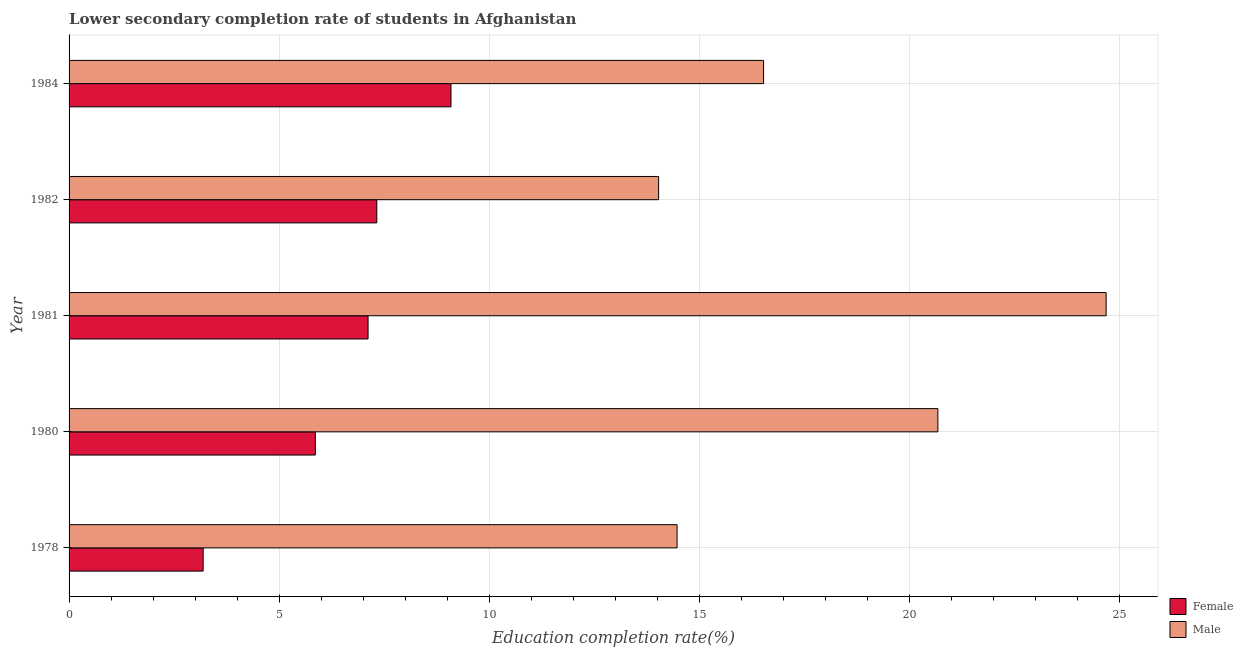How many different coloured bars are there?
Make the answer very short. 2. How many groups of bars are there?
Keep it short and to the point. 5. Are the number of bars per tick equal to the number of legend labels?
Your answer should be compact. Yes. Are the number of bars on each tick of the Y-axis equal?
Offer a very short reply. Yes. In how many cases, is the number of bars for a given year not equal to the number of legend labels?
Ensure brevity in your answer.  0. What is the education completion rate of male students in 1981?
Ensure brevity in your answer.  24.69. Across all years, what is the maximum education completion rate of male students?
Keep it short and to the point. 24.69. Across all years, what is the minimum education completion rate of male students?
Provide a succinct answer. 14.03. In which year was the education completion rate of male students maximum?
Ensure brevity in your answer.  1981. In which year was the education completion rate of female students minimum?
Provide a succinct answer. 1978. What is the total education completion rate of female students in the graph?
Provide a short and direct response. 32.59. What is the difference between the education completion rate of female students in 1982 and that in 1984?
Your response must be concise. -1.77. What is the difference between the education completion rate of female students in 1980 and the education completion rate of male students in 1984?
Provide a short and direct response. -10.67. What is the average education completion rate of female students per year?
Your answer should be very brief. 6.52. In the year 1982, what is the difference between the education completion rate of female students and education completion rate of male students?
Your response must be concise. -6.71. What is the ratio of the education completion rate of female students in 1981 to that in 1984?
Your answer should be very brief. 0.78. Is the education completion rate of male students in 1981 less than that in 1982?
Make the answer very short. No. Is the difference between the education completion rate of male students in 1978 and 1984 greater than the difference between the education completion rate of female students in 1978 and 1984?
Offer a very short reply. Yes. What is the difference between the highest and the second highest education completion rate of male students?
Make the answer very short. 4. What is the difference between the highest and the lowest education completion rate of male students?
Provide a short and direct response. 10.65. Is the sum of the education completion rate of female students in 1978 and 1980 greater than the maximum education completion rate of male students across all years?
Your answer should be compact. No. What does the 2nd bar from the top in 1984 represents?
Ensure brevity in your answer.  Female. What does the 1st bar from the bottom in 1978 represents?
Your answer should be very brief. Female. Are all the bars in the graph horizontal?
Ensure brevity in your answer.  Yes. How many years are there in the graph?
Provide a succinct answer. 5. What is the difference between two consecutive major ticks on the X-axis?
Your response must be concise. 5. Are the values on the major ticks of X-axis written in scientific E-notation?
Keep it short and to the point. No. Does the graph contain any zero values?
Your answer should be compact. No. Where does the legend appear in the graph?
Offer a terse response. Bottom right. What is the title of the graph?
Provide a succinct answer. Lower secondary completion rate of students in Afghanistan. What is the label or title of the X-axis?
Make the answer very short. Education completion rate(%). What is the Education completion rate(%) in Female in 1978?
Your answer should be compact. 3.19. What is the Education completion rate(%) in Male in 1978?
Provide a succinct answer. 14.47. What is the Education completion rate(%) of Female in 1980?
Your answer should be very brief. 5.86. What is the Education completion rate(%) in Male in 1980?
Offer a terse response. 20.68. What is the Education completion rate(%) of Female in 1981?
Give a very brief answer. 7.12. What is the Education completion rate(%) in Male in 1981?
Provide a succinct answer. 24.69. What is the Education completion rate(%) in Female in 1982?
Your response must be concise. 7.33. What is the Education completion rate(%) of Male in 1982?
Your response must be concise. 14.03. What is the Education completion rate(%) of Female in 1984?
Your answer should be compact. 9.09. What is the Education completion rate(%) of Male in 1984?
Ensure brevity in your answer.  16.53. Across all years, what is the maximum Education completion rate(%) of Female?
Keep it short and to the point. 9.09. Across all years, what is the maximum Education completion rate(%) of Male?
Make the answer very short. 24.69. Across all years, what is the minimum Education completion rate(%) of Female?
Keep it short and to the point. 3.19. Across all years, what is the minimum Education completion rate(%) in Male?
Make the answer very short. 14.03. What is the total Education completion rate(%) in Female in the graph?
Ensure brevity in your answer.  32.59. What is the total Education completion rate(%) in Male in the graph?
Offer a very short reply. 90.41. What is the difference between the Education completion rate(%) in Female in 1978 and that in 1980?
Ensure brevity in your answer.  -2.67. What is the difference between the Education completion rate(%) of Male in 1978 and that in 1980?
Offer a terse response. -6.21. What is the difference between the Education completion rate(%) in Female in 1978 and that in 1981?
Offer a very short reply. -3.93. What is the difference between the Education completion rate(%) in Male in 1978 and that in 1981?
Offer a terse response. -10.21. What is the difference between the Education completion rate(%) of Female in 1978 and that in 1982?
Your response must be concise. -4.13. What is the difference between the Education completion rate(%) in Male in 1978 and that in 1982?
Keep it short and to the point. 0.44. What is the difference between the Education completion rate(%) of Female in 1978 and that in 1984?
Offer a terse response. -5.9. What is the difference between the Education completion rate(%) in Male in 1978 and that in 1984?
Keep it short and to the point. -2.06. What is the difference between the Education completion rate(%) in Female in 1980 and that in 1981?
Offer a very short reply. -1.25. What is the difference between the Education completion rate(%) in Male in 1980 and that in 1981?
Your answer should be compact. -4.01. What is the difference between the Education completion rate(%) of Female in 1980 and that in 1982?
Your answer should be very brief. -1.46. What is the difference between the Education completion rate(%) in Male in 1980 and that in 1982?
Give a very brief answer. 6.65. What is the difference between the Education completion rate(%) in Female in 1980 and that in 1984?
Provide a succinct answer. -3.23. What is the difference between the Education completion rate(%) in Male in 1980 and that in 1984?
Provide a succinct answer. 4.15. What is the difference between the Education completion rate(%) of Female in 1981 and that in 1982?
Provide a succinct answer. -0.21. What is the difference between the Education completion rate(%) in Male in 1981 and that in 1982?
Provide a succinct answer. 10.65. What is the difference between the Education completion rate(%) in Female in 1981 and that in 1984?
Your response must be concise. -1.97. What is the difference between the Education completion rate(%) in Male in 1981 and that in 1984?
Provide a short and direct response. 8.15. What is the difference between the Education completion rate(%) of Female in 1982 and that in 1984?
Provide a succinct answer. -1.77. What is the difference between the Education completion rate(%) in Male in 1982 and that in 1984?
Give a very brief answer. -2.5. What is the difference between the Education completion rate(%) of Female in 1978 and the Education completion rate(%) of Male in 1980?
Make the answer very short. -17.49. What is the difference between the Education completion rate(%) in Female in 1978 and the Education completion rate(%) in Male in 1981?
Keep it short and to the point. -21.49. What is the difference between the Education completion rate(%) in Female in 1978 and the Education completion rate(%) in Male in 1982?
Provide a short and direct response. -10.84. What is the difference between the Education completion rate(%) in Female in 1978 and the Education completion rate(%) in Male in 1984?
Make the answer very short. -13.34. What is the difference between the Education completion rate(%) in Female in 1980 and the Education completion rate(%) in Male in 1981?
Make the answer very short. -18.82. What is the difference between the Education completion rate(%) in Female in 1980 and the Education completion rate(%) in Male in 1982?
Your answer should be compact. -8.17. What is the difference between the Education completion rate(%) in Female in 1980 and the Education completion rate(%) in Male in 1984?
Offer a very short reply. -10.67. What is the difference between the Education completion rate(%) of Female in 1981 and the Education completion rate(%) of Male in 1982?
Offer a terse response. -6.92. What is the difference between the Education completion rate(%) in Female in 1981 and the Education completion rate(%) in Male in 1984?
Ensure brevity in your answer.  -9.41. What is the difference between the Education completion rate(%) in Female in 1982 and the Education completion rate(%) in Male in 1984?
Provide a short and direct response. -9.21. What is the average Education completion rate(%) of Female per year?
Make the answer very short. 6.52. What is the average Education completion rate(%) in Male per year?
Offer a terse response. 18.08. In the year 1978, what is the difference between the Education completion rate(%) in Female and Education completion rate(%) in Male?
Your answer should be very brief. -11.28. In the year 1980, what is the difference between the Education completion rate(%) in Female and Education completion rate(%) in Male?
Give a very brief answer. -14.82. In the year 1981, what is the difference between the Education completion rate(%) in Female and Education completion rate(%) in Male?
Give a very brief answer. -17.57. In the year 1982, what is the difference between the Education completion rate(%) of Female and Education completion rate(%) of Male?
Provide a succinct answer. -6.71. In the year 1984, what is the difference between the Education completion rate(%) in Female and Education completion rate(%) in Male?
Offer a terse response. -7.44. What is the ratio of the Education completion rate(%) of Female in 1978 to that in 1980?
Give a very brief answer. 0.54. What is the ratio of the Education completion rate(%) in Male in 1978 to that in 1980?
Your answer should be very brief. 0.7. What is the ratio of the Education completion rate(%) in Female in 1978 to that in 1981?
Ensure brevity in your answer.  0.45. What is the ratio of the Education completion rate(%) of Male in 1978 to that in 1981?
Your response must be concise. 0.59. What is the ratio of the Education completion rate(%) in Female in 1978 to that in 1982?
Your response must be concise. 0.44. What is the ratio of the Education completion rate(%) in Male in 1978 to that in 1982?
Your response must be concise. 1.03. What is the ratio of the Education completion rate(%) of Female in 1978 to that in 1984?
Your answer should be compact. 0.35. What is the ratio of the Education completion rate(%) of Male in 1978 to that in 1984?
Your response must be concise. 0.88. What is the ratio of the Education completion rate(%) in Female in 1980 to that in 1981?
Keep it short and to the point. 0.82. What is the ratio of the Education completion rate(%) of Male in 1980 to that in 1981?
Keep it short and to the point. 0.84. What is the ratio of the Education completion rate(%) in Female in 1980 to that in 1982?
Give a very brief answer. 0.8. What is the ratio of the Education completion rate(%) in Male in 1980 to that in 1982?
Make the answer very short. 1.47. What is the ratio of the Education completion rate(%) in Female in 1980 to that in 1984?
Offer a terse response. 0.64. What is the ratio of the Education completion rate(%) of Male in 1980 to that in 1984?
Your response must be concise. 1.25. What is the ratio of the Education completion rate(%) of Female in 1981 to that in 1982?
Make the answer very short. 0.97. What is the ratio of the Education completion rate(%) of Male in 1981 to that in 1982?
Provide a succinct answer. 1.76. What is the ratio of the Education completion rate(%) in Female in 1981 to that in 1984?
Provide a short and direct response. 0.78. What is the ratio of the Education completion rate(%) in Male in 1981 to that in 1984?
Offer a very short reply. 1.49. What is the ratio of the Education completion rate(%) of Female in 1982 to that in 1984?
Your answer should be very brief. 0.81. What is the ratio of the Education completion rate(%) in Male in 1982 to that in 1984?
Keep it short and to the point. 0.85. What is the difference between the highest and the second highest Education completion rate(%) of Female?
Provide a succinct answer. 1.77. What is the difference between the highest and the second highest Education completion rate(%) in Male?
Keep it short and to the point. 4.01. What is the difference between the highest and the lowest Education completion rate(%) in Female?
Make the answer very short. 5.9. What is the difference between the highest and the lowest Education completion rate(%) in Male?
Provide a succinct answer. 10.65. 